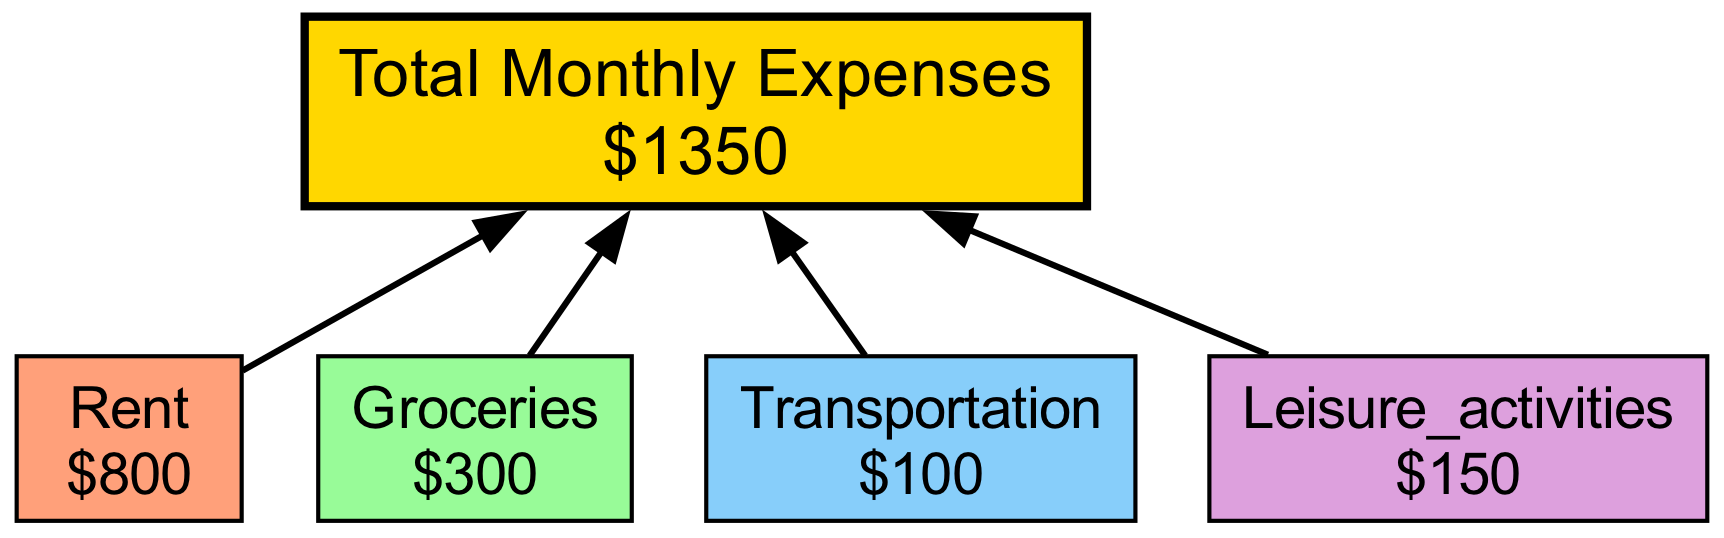What is the average cost of rent? The diagram shows the breakdown of monthly expenses, and under the "rent" node, it states the average cost is $800.
Answer: $800 What are the total monthly expenses? The total monthly expenses are shown in the "total" node, stating a cost of $1350 in bold.
Answer: $1350 How much is allocated for groceries? Looking at the "groceries" node, the diagram indicates the average monthly expense for groceries is $300.
Answer: $300 Which expense category has the least budget? The categories include rent, groceries, transportation, and leisure activities. Among them, "transportation" has the lowest average cost at $100.
Answer: Transportation How many expense categories are detailed in the diagram? The diagram outlines 4 specific expense categories: rent, groceries, transportation, and leisure activities, which can be counted visually.
Answer: 4 What do the colored nodes represent? The colored nodes in the diagram represent different expense categories, each with an average cost associated with it, shown in a visual format.
Answer: Expense categories If you sum up rent and groceries, what is the total? The rent is $800, and groceries are $300. Adding these two amounts gives $800 + $300 = $1100.
Answer: $1100 Which expense category accounts for entertainment? The "leisure activities" category is specifically designated for entertainment, dining out, and social activities in the student budget.
Answer: Leisure activities How does the total relate to the individual expenses? The total monthly expenses node is connected to all individual expense category nodes, signifying that these categories contribute to the total of $1350.
Answer: Total monthly expense 